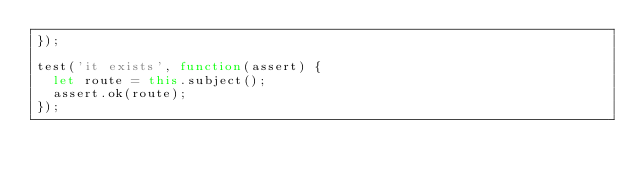Convert code to text. <code><loc_0><loc_0><loc_500><loc_500><_JavaScript_>});

test('it exists', function(assert) {
  let route = this.subject();
  assert.ok(route);
});
</code> 